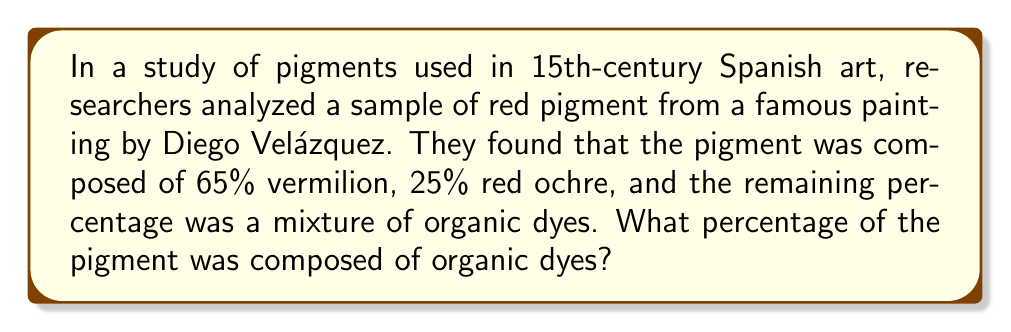Can you answer this question? Let's approach this step-by-step:

1) First, we need to understand what the question is asking. We're looking for the percentage of organic dyes in the pigment.

2) We're given two percentages:
   - Vermilion: 65%
   - Red ochre: 25%

3) We know that the total of all components must equal 100%. We can express this as an equation:

   $$\text{Vermilion} + \text{Red ochre} + \text{Organic dyes} = 100\%$$

4) Let's substitute the known values:

   $$65\% + 25\% + \text{Organic dyes} = 100\%$$

5) Now we can solve for the percentage of organic dyes:

   $$\text{Organic dyes} = 100\% - (65\% + 25\%)$$
   $$\text{Organic dyes} = 100\% - 90\%$$
   $$\text{Organic dyes} = 10\%$$

Therefore, the percentage of the pigment composed of organic dyes is 10%.
Answer: 10% 